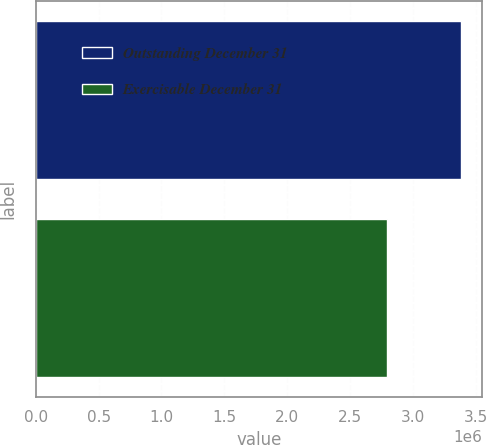Convert chart to OTSL. <chart><loc_0><loc_0><loc_500><loc_500><bar_chart><fcel>Outstanding December 31<fcel>Exercisable December 31<nl><fcel>3.38455e+06<fcel>2.79446e+06<nl></chart> 